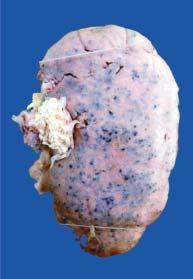what does the cortex show?
Answer the question using a single word or phrase. Characteristic 'flea bitten kidney ' 